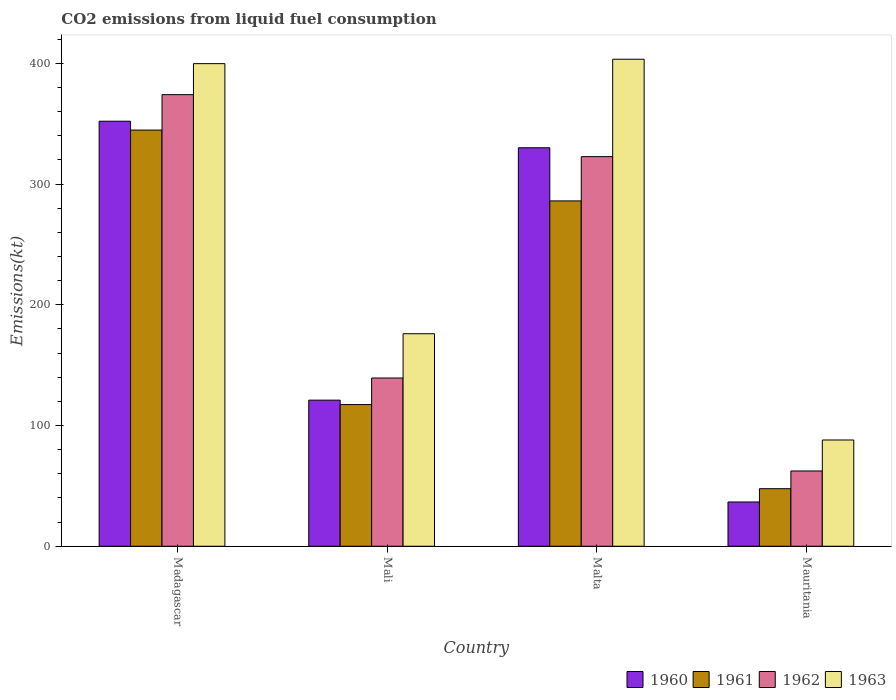How many different coloured bars are there?
Provide a short and direct response. 4. Are the number of bars on each tick of the X-axis equal?
Provide a short and direct response. Yes. How many bars are there on the 3rd tick from the right?
Your answer should be very brief. 4. What is the label of the 4th group of bars from the left?
Provide a short and direct response. Mauritania. What is the amount of CO2 emitted in 1961 in Mali?
Keep it short and to the point. 117.34. Across all countries, what is the maximum amount of CO2 emitted in 1961?
Your response must be concise. 344.7. Across all countries, what is the minimum amount of CO2 emitted in 1963?
Ensure brevity in your answer.  88.01. In which country was the amount of CO2 emitted in 1960 maximum?
Provide a short and direct response. Madagascar. In which country was the amount of CO2 emitted in 1962 minimum?
Provide a succinct answer. Mauritania. What is the total amount of CO2 emitted in 1960 in the graph?
Your response must be concise. 839.74. What is the difference between the amount of CO2 emitted in 1960 in Mali and that in Mauritania?
Your answer should be very brief. 84.34. What is the difference between the amount of CO2 emitted in 1961 in Mali and the amount of CO2 emitted in 1962 in Madagascar?
Offer a very short reply. -256.69. What is the average amount of CO2 emitted in 1963 per country?
Your answer should be compact. 266.77. What is the difference between the amount of CO2 emitted of/in 1961 and amount of CO2 emitted of/in 1960 in Mauritania?
Your answer should be compact. 11. What is the ratio of the amount of CO2 emitted in 1962 in Mali to that in Mauritania?
Ensure brevity in your answer.  2.24. Is the amount of CO2 emitted in 1963 in Mali less than that in Malta?
Give a very brief answer. Yes. Is the difference between the amount of CO2 emitted in 1961 in Malta and Mauritania greater than the difference between the amount of CO2 emitted in 1960 in Malta and Mauritania?
Make the answer very short. No. What is the difference between the highest and the second highest amount of CO2 emitted in 1962?
Provide a succinct answer. 183.35. What is the difference between the highest and the lowest amount of CO2 emitted in 1962?
Give a very brief answer. 311.69. In how many countries, is the amount of CO2 emitted in 1962 greater than the average amount of CO2 emitted in 1962 taken over all countries?
Give a very brief answer. 2. Is it the case that in every country, the sum of the amount of CO2 emitted in 1962 and amount of CO2 emitted in 1961 is greater than the sum of amount of CO2 emitted in 1963 and amount of CO2 emitted in 1960?
Offer a very short reply. No. What does the 4th bar from the right in Madagascar represents?
Ensure brevity in your answer.  1960. Is it the case that in every country, the sum of the amount of CO2 emitted in 1960 and amount of CO2 emitted in 1963 is greater than the amount of CO2 emitted in 1962?
Your answer should be compact. Yes. How many bars are there?
Provide a succinct answer. 16. Are all the bars in the graph horizontal?
Ensure brevity in your answer.  No. How many countries are there in the graph?
Your response must be concise. 4. Does the graph contain grids?
Keep it short and to the point. No. Where does the legend appear in the graph?
Your answer should be compact. Bottom right. What is the title of the graph?
Offer a terse response. CO2 emissions from liquid fuel consumption. Does "2006" appear as one of the legend labels in the graph?
Your answer should be very brief. No. What is the label or title of the X-axis?
Offer a very short reply. Country. What is the label or title of the Y-axis?
Your response must be concise. Emissions(kt). What is the Emissions(kt) of 1960 in Madagascar?
Your answer should be compact. 352.03. What is the Emissions(kt) of 1961 in Madagascar?
Provide a short and direct response. 344.7. What is the Emissions(kt) in 1962 in Madagascar?
Your answer should be compact. 374.03. What is the Emissions(kt) in 1963 in Madagascar?
Your response must be concise. 399.7. What is the Emissions(kt) of 1960 in Mali?
Provide a succinct answer. 121.01. What is the Emissions(kt) in 1961 in Mali?
Your answer should be very brief. 117.34. What is the Emissions(kt) in 1962 in Mali?
Give a very brief answer. 139.35. What is the Emissions(kt) in 1963 in Mali?
Offer a very short reply. 176.02. What is the Emissions(kt) of 1960 in Malta?
Your response must be concise. 330.03. What is the Emissions(kt) in 1961 in Malta?
Your response must be concise. 286.03. What is the Emissions(kt) in 1962 in Malta?
Give a very brief answer. 322.7. What is the Emissions(kt) in 1963 in Malta?
Your answer should be compact. 403.37. What is the Emissions(kt) of 1960 in Mauritania?
Make the answer very short. 36.67. What is the Emissions(kt) of 1961 in Mauritania?
Your response must be concise. 47.67. What is the Emissions(kt) in 1962 in Mauritania?
Provide a short and direct response. 62.34. What is the Emissions(kt) of 1963 in Mauritania?
Your answer should be very brief. 88.01. Across all countries, what is the maximum Emissions(kt) in 1960?
Ensure brevity in your answer.  352.03. Across all countries, what is the maximum Emissions(kt) in 1961?
Give a very brief answer. 344.7. Across all countries, what is the maximum Emissions(kt) in 1962?
Offer a terse response. 374.03. Across all countries, what is the maximum Emissions(kt) in 1963?
Offer a terse response. 403.37. Across all countries, what is the minimum Emissions(kt) in 1960?
Your answer should be very brief. 36.67. Across all countries, what is the minimum Emissions(kt) of 1961?
Your answer should be compact. 47.67. Across all countries, what is the minimum Emissions(kt) of 1962?
Your answer should be compact. 62.34. Across all countries, what is the minimum Emissions(kt) of 1963?
Make the answer very short. 88.01. What is the total Emissions(kt) in 1960 in the graph?
Your response must be concise. 839.74. What is the total Emissions(kt) in 1961 in the graph?
Your response must be concise. 795.74. What is the total Emissions(kt) of 1962 in the graph?
Make the answer very short. 898.41. What is the total Emissions(kt) of 1963 in the graph?
Ensure brevity in your answer.  1067.1. What is the difference between the Emissions(kt) of 1960 in Madagascar and that in Mali?
Keep it short and to the point. 231.02. What is the difference between the Emissions(kt) of 1961 in Madagascar and that in Mali?
Ensure brevity in your answer.  227.35. What is the difference between the Emissions(kt) in 1962 in Madagascar and that in Mali?
Make the answer very short. 234.69. What is the difference between the Emissions(kt) of 1963 in Madagascar and that in Mali?
Your answer should be compact. 223.69. What is the difference between the Emissions(kt) in 1960 in Madagascar and that in Malta?
Make the answer very short. 22. What is the difference between the Emissions(kt) in 1961 in Madagascar and that in Malta?
Offer a terse response. 58.67. What is the difference between the Emissions(kt) of 1962 in Madagascar and that in Malta?
Provide a short and direct response. 51.34. What is the difference between the Emissions(kt) in 1963 in Madagascar and that in Malta?
Provide a succinct answer. -3.67. What is the difference between the Emissions(kt) in 1960 in Madagascar and that in Mauritania?
Make the answer very short. 315.36. What is the difference between the Emissions(kt) of 1961 in Madagascar and that in Mauritania?
Ensure brevity in your answer.  297.03. What is the difference between the Emissions(kt) of 1962 in Madagascar and that in Mauritania?
Your answer should be compact. 311.69. What is the difference between the Emissions(kt) of 1963 in Madagascar and that in Mauritania?
Provide a succinct answer. 311.69. What is the difference between the Emissions(kt) in 1960 in Mali and that in Malta?
Provide a short and direct response. -209.02. What is the difference between the Emissions(kt) in 1961 in Mali and that in Malta?
Your answer should be compact. -168.68. What is the difference between the Emissions(kt) of 1962 in Mali and that in Malta?
Make the answer very short. -183.35. What is the difference between the Emissions(kt) in 1963 in Mali and that in Malta?
Your response must be concise. -227.35. What is the difference between the Emissions(kt) in 1960 in Mali and that in Mauritania?
Make the answer very short. 84.34. What is the difference between the Emissions(kt) of 1961 in Mali and that in Mauritania?
Give a very brief answer. 69.67. What is the difference between the Emissions(kt) in 1962 in Mali and that in Mauritania?
Your response must be concise. 77.01. What is the difference between the Emissions(kt) in 1963 in Mali and that in Mauritania?
Offer a very short reply. 88.01. What is the difference between the Emissions(kt) of 1960 in Malta and that in Mauritania?
Give a very brief answer. 293.36. What is the difference between the Emissions(kt) of 1961 in Malta and that in Mauritania?
Offer a terse response. 238.35. What is the difference between the Emissions(kt) of 1962 in Malta and that in Mauritania?
Ensure brevity in your answer.  260.36. What is the difference between the Emissions(kt) in 1963 in Malta and that in Mauritania?
Provide a succinct answer. 315.36. What is the difference between the Emissions(kt) in 1960 in Madagascar and the Emissions(kt) in 1961 in Mali?
Your response must be concise. 234.69. What is the difference between the Emissions(kt) in 1960 in Madagascar and the Emissions(kt) in 1962 in Mali?
Your answer should be very brief. 212.69. What is the difference between the Emissions(kt) of 1960 in Madagascar and the Emissions(kt) of 1963 in Mali?
Make the answer very short. 176.02. What is the difference between the Emissions(kt) of 1961 in Madagascar and the Emissions(kt) of 1962 in Mali?
Provide a succinct answer. 205.35. What is the difference between the Emissions(kt) in 1961 in Madagascar and the Emissions(kt) in 1963 in Mali?
Give a very brief answer. 168.68. What is the difference between the Emissions(kt) in 1962 in Madagascar and the Emissions(kt) in 1963 in Mali?
Offer a terse response. 198.02. What is the difference between the Emissions(kt) of 1960 in Madagascar and the Emissions(kt) of 1961 in Malta?
Offer a terse response. 66.01. What is the difference between the Emissions(kt) in 1960 in Madagascar and the Emissions(kt) in 1962 in Malta?
Make the answer very short. 29.34. What is the difference between the Emissions(kt) in 1960 in Madagascar and the Emissions(kt) in 1963 in Malta?
Offer a very short reply. -51.34. What is the difference between the Emissions(kt) in 1961 in Madagascar and the Emissions(kt) in 1962 in Malta?
Provide a short and direct response. 22. What is the difference between the Emissions(kt) in 1961 in Madagascar and the Emissions(kt) in 1963 in Malta?
Keep it short and to the point. -58.67. What is the difference between the Emissions(kt) of 1962 in Madagascar and the Emissions(kt) of 1963 in Malta?
Give a very brief answer. -29.34. What is the difference between the Emissions(kt) of 1960 in Madagascar and the Emissions(kt) of 1961 in Mauritania?
Offer a terse response. 304.36. What is the difference between the Emissions(kt) in 1960 in Madagascar and the Emissions(kt) in 1962 in Mauritania?
Offer a very short reply. 289.69. What is the difference between the Emissions(kt) of 1960 in Madagascar and the Emissions(kt) of 1963 in Mauritania?
Give a very brief answer. 264.02. What is the difference between the Emissions(kt) in 1961 in Madagascar and the Emissions(kt) in 1962 in Mauritania?
Offer a terse response. 282.36. What is the difference between the Emissions(kt) of 1961 in Madagascar and the Emissions(kt) of 1963 in Mauritania?
Give a very brief answer. 256.69. What is the difference between the Emissions(kt) in 1962 in Madagascar and the Emissions(kt) in 1963 in Mauritania?
Offer a very short reply. 286.03. What is the difference between the Emissions(kt) of 1960 in Mali and the Emissions(kt) of 1961 in Malta?
Your answer should be compact. -165.01. What is the difference between the Emissions(kt) in 1960 in Mali and the Emissions(kt) in 1962 in Malta?
Give a very brief answer. -201.69. What is the difference between the Emissions(kt) of 1960 in Mali and the Emissions(kt) of 1963 in Malta?
Make the answer very short. -282.36. What is the difference between the Emissions(kt) in 1961 in Mali and the Emissions(kt) in 1962 in Malta?
Your answer should be compact. -205.35. What is the difference between the Emissions(kt) of 1961 in Mali and the Emissions(kt) of 1963 in Malta?
Ensure brevity in your answer.  -286.03. What is the difference between the Emissions(kt) in 1962 in Mali and the Emissions(kt) in 1963 in Malta?
Provide a short and direct response. -264.02. What is the difference between the Emissions(kt) of 1960 in Mali and the Emissions(kt) of 1961 in Mauritania?
Ensure brevity in your answer.  73.34. What is the difference between the Emissions(kt) of 1960 in Mali and the Emissions(kt) of 1962 in Mauritania?
Ensure brevity in your answer.  58.67. What is the difference between the Emissions(kt) in 1960 in Mali and the Emissions(kt) in 1963 in Mauritania?
Ensure brevity in your answer.  33. What is the difference between the Emissions(kt) in 1961 in Mali and the Emissions(kt) in 1962 in Mauritania?
Your answer should be compact. 55.01. What is the difference between the Emissions(kt) of 1961 in Mali and the Emissions(kt) of 1963 in Mauritania?
Offer a terse response. 29.34. What is the difference between the Emissions(kt) of 1962 in Mali and the Emissions(kt) of 1963 in Mauritania?
Your response must be concise. 51.34. What is the difference between the Emissions(kt) in 1960 in Malta and the Emissions(kt) in 1961 in Mauritania?
Your answer should be very brief. 282.36. What is the difference between the Emissions(kt) in 1960 in Malta and the Emissions(kt) in 1962 in Mauritania?
Ensure brevity in your answer.  267.69. What is the difference between the Emissions(kt) in 1960 in Malta and the Emissions(kt) in 1963 in Mauritania?
Give a very brief answer. 242.02. What is the difference between the Emissions(kt) of 1961 in Malta and the Emissions(kt) of 1962 in Mauritania?
Ensure brevity in your answer.  223.69. What is the difference between the Emissions(kt) in 1961 in Malta and the Emissions(kt) in 1963 in Mauritania?
Your response must be concise. 198.02. What is the difference between the Emissions(kt) of 1962 in Malta and the Emissions(kt) of 1963 in Mauritania?
Offer a terse response. 234.69. What is the average Emissions(kt) of 1960 per country?
Your answer should be very brief. 209.94. What is the average Emissions(kt) in 1961 per country?
Provide a short and direct response. 198.93. What is the average Emissions(kt) of 1962 per country?
Offer a very short reply. 224.6. What is the average Emissions(kt) in 1963 per country?
Give a very brief answer. 266.77. What is the difference between the Emissions(kt) in 1960 and Emissions(kt) in 1961 in Madagascar?
Give a very brief answer. 7.33. What is the difference between the Emissions(kt) in 1960 and Emissions(kt) in 1962 in Madagascar?
Your response must be concise. -22. What is the difference between the Emissions(kt) in 1960 and Emissions(kt) in 1963 in Madagascar?
Provide a short and direct response. -47.67. What is the difference between the Emissions(kt) of 1961 and Emissions(kt) of 1962 in Madagascar?
Ensure brevity in your answer.  -29.34. What is the difference between the Emissions(kt) in 1961 and Emissions(kt) in 1963 in Madagascar?
Provide a short and direct response. -55.01. What is the difference between the Emissions(kt) of 1962 and Emissions(kt) of 1963 in Madagascar?
Provide a succinct answer. -25.67. What is the difference between the Emissions(kt) of 1960 and Emissions(kt) of 1961 in Mali?
Provide a succinct answer. 3.67. What is the difference between the Emissions(kt) in 1960 and Emissions(kt) in 1962 in Mali?
Your response must be concise. -18.34. What is the difference between the Emissions(kt) of 1960 and Emissions(kt) of 1963 in Mali?
Your answer should be very brief. -55.01. What is the difference between the Emissions(kt) of 1961 and Emissions(kt) of 1962 in Mali?
Your response must be concise. -22. What is the difference between the Emissions(kt) of 1961 and Emissions(kt) of 1963 in Mali?
Offer a very short reply. -58.67. What is the difference between the Emissions(kt) of 1962 and Emissions(kt) of 1963 in Mali?
Give a very brief answer. -36.67. What is the difference between the Emissions(kt) of 1960 and Emissions(kt) of 1961 in Malta?
Give a very brief answer. 44. What is the difference between the Emissions(kt) of 1960 and Emissions(kt) of 1962 in Malta?
Offer a terse response. 7.33. What is the difference between the Emissions(kt) of 1960 and Emissions(kt) of 1963 in Malta?
Your answer should be compact. -73.34. What is the difference between the Emissions(kt) in 1961 and Emissions(kt) in 1962 in Malta?
Your answer should be very brief. -36.67. What is the difference between the Emissions(kt) of 1961 and Emissions(kt) of 1963 in Malta?
Provide a short and direct response. -117.34. What is the difference between the Emissions(kt) in 1962 and Emissions(kt) in 1963 in Malta?
Offer a very short reply. -80.67. What is the difference between the Emissions(kt) of 1960 and Emissions(kt) of 1961 in Mauritania?
Provide a short and direct response. -11. What is the difference between the Emissions(kt) in 1960 and Emissions(kt) in 1962 in Mauritania?
Your answer should be compact. -25.67. What is the difference between the Emissions(kt) in 1960 and Emissions(kt) in 1963 in Mauritania?
Keep it short and to the point. -51.34. What is the difference between the Emissions(kt) in 1961 and Emissions(kt) in 1962 in Mauritania?
Keep it short and to the point. -14.67. What is the difference between the Emissions(kt) in 1961 and Emissions(kt) in 1963 in Mauritania?
Offer a terse response. -40.34. What is the difference between the Emissions(kt) in 1962 and Emissions(kt) in 1963 in Mauritania?
Your answer should be very brief. -25.67. What is the ratio of the Emissions(kt) of 1960 in Madagascar to that in Mali?
Give a very brief answer. 2.91. What is the ratio of the Emissions(kt) in 1961 in Madagascar to that in Mali?
Your answer should be compact. 2.94. What is the ratio of the Emissions(kt) of 1962 in Madagascar to that in Mali?
Your answer should be very brief. 2.68. What is the ratio of the Emissions(kt) of 1963 in Madagascar to that in Mali?
Offer a terse response. 2.27. What is the ratio of the Emissions(kt) in 1960 in Madagascar to that in Malta?
Your response must be concise. 1.07. What is the ratio of the Emissions(kt) in 1961 in Madagascar to that in Malta?
Provide a succinct answer. 1.21. What is the ratio of the Emissions(kt) in 1962 in Madagascar to that in Malta?
Your response must be concise. 1.16. What is the ratio of the Emissions(kt) in 1963 in Madagascar to that in Malta?
Your response must be concise. 0.99. What is the ratio of the Emissions(kt) of 1961 in Madagascar to that in Mauritania?
Give a very brief answer. 7.23. What is the ratio of the Emissions(kt) of 1962 in Madagascar to that in Mauritania?
Offer a very short reply. 6. What is the ratio of the Emissions(kt) of 1963 in Madagascar to that in Mauritania?
Provide a succinct answer. 4.54. What is the ratio of the Emissions(kt) of 1960 in Mali to that in Malta?
Provide a succinct answer. 0.37. What is the ratio of the Emissions(kt) of 1961 in Mali to that in Malta?
Your answer should be compact. 0.41. What is the ratio of the Emissions(kt) of 1962 in Mali to that in Malta?
Offer a very short reply. 0.43. What is the ratio of the Emissions(kt) in 1963 in Mali to that in Malta?
Ensure brevity in your answer.  0.44. What is the ratio of the Emissions(kt) in 1961 in Mali to that in Mauritania?
Offer a very short reply. 2.46. What is the ratio of the Emissions(kt) of 1962 in Mali to that in Mauritania?
Ensure brevity in your answer.  2.24. What is the ratio of the Emissions(kt) of 1960 in Malta to that in Mauritania?
Keep it short and to the point. 9. What is the ratio of the Emissions(kt) in 1962 in Malta to that in Mauritania?
Your answer should be compact. 5.18. What is the ratio of the Emissions(kt) of 1963 in Malta to that in Mauritania?
Keep it short and to the point. 4.58. What is the difference between the highest and the second highest Emissions(kt) in 1960?
Offer a terse response. 22. What is the difference between the highest and the second highest Emissions(kt) in 1961?
Provide a succinct answer. 58.67. What is the difference between the highest and the second highest Emissions(kt) in 1962?
Your answer should be compact. 51.34. What is the difference between the highest and the second highest Emissions(kt) of 1963?
Keep it short and to the point. 3.67. What is the difference between the highest and the lowest Emissions(kt) in 1960?
Your answer should be compact. 315.36. What is the difference between the highest and the lowest Emissions(kt) of 1961?
Keep it short and to the point. 297.03. What is the difference between the highest and the lowest Emissions(kt) in 1962?
Ensure brevity in your answer.  311.69. What is the difference between the highest and the lowest Emissions(kt) in 1963?
Give a very brief answer. 315.36. 